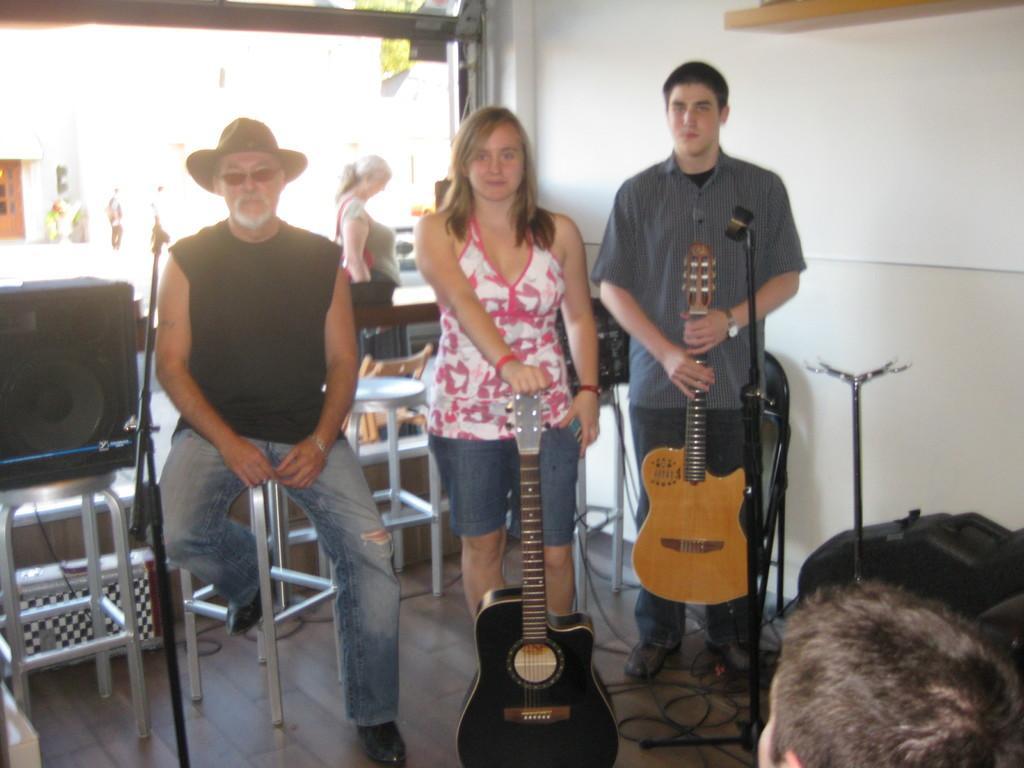How would you summarize this image in a sentence or two? In this image there are two persons who are standing and they are holding guitars. On the left side there is one person who is sitting beside him there is one sound system. On the background there is a wall and on the bottom there are some wires and on the top of the left corner there is a door. 